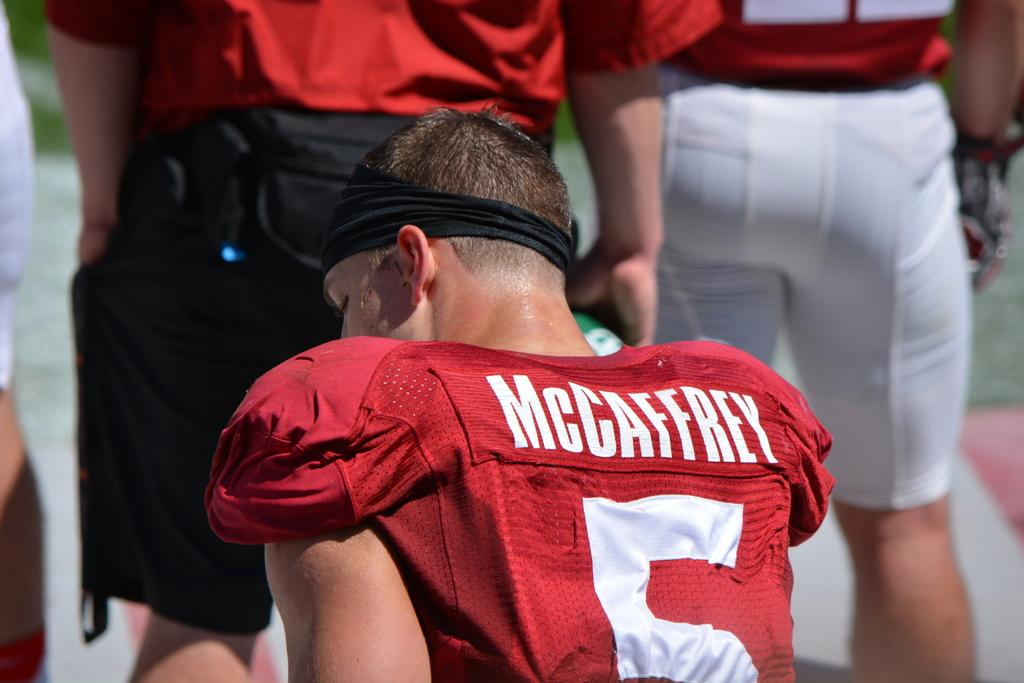What can be seen in the image? There are people in the image. What are the people wearing? The people are wearing red color clothes. Can you describe the background of the image? The background of the image is blurred. How many pies are being held by the people in the image? There is no mention of pies in the image, so it cannot be determined if any are being held. 